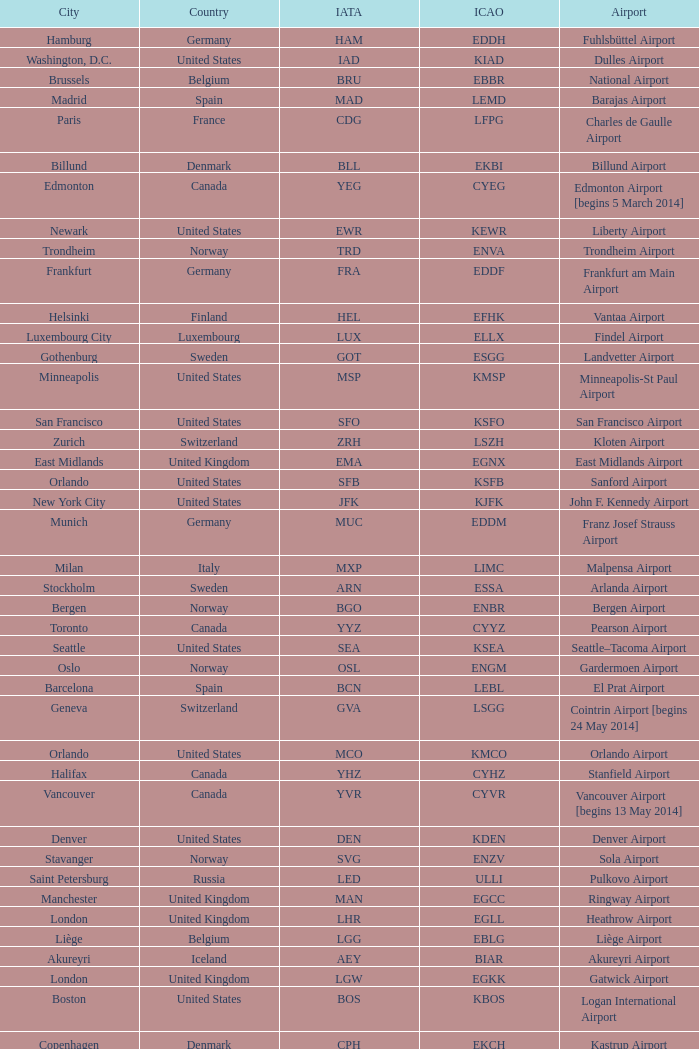What is the City with an IATA of MUC? Munich. Give me the full table as a dictionary. {'header': ['City', 'Country', 'IATA', 'ICAO', 'Airport'], 'rows': [['Hamburg', 'Germany', 'HAM', 'EDDH', 'Fuhlsbüttel Airport'], ['Washington, D.C.', 'United States', 'IAD', 'KIAD', 'Dulles Airport'], ['Brussels', 'Belgium', 'BRU', 'EBBR', 'National Airport'], ['Madrid', 'Spain', 'MAD', 'LEMD', 'Barajas Airport'], ['Paris', 'France', 'CDG', 'LFPG', 'Charles de Gaulle Airport'], ['Billund', 'Denmark', 'BLL', 'EKBI', 'Billund Airport'], ['Edmonton', 'Canada', 'YEG', 'CYEG', 'Edmonton Airport [begins 5 March 2014]'], ['Newark', 'United States', 'EWR', 'KEWR', 'Liberty Airport'], ['Trondheim', 'Norway', 'TRD', 'ENVA', 'Trondheim Airport'], ['Frankfurt', 'Germany', 'FRA', 'EDDF', 'Frankfurt am Main Airport'], ['Helsinki', 'Finland', 'HEL', 'EFHK', 'Vantaa Airport'], ['Luxembourg City', 'Luxembourg', 'LUX', 'ELLX', 'Findel Airport'], ['Gothenburg', 'Sweden', 'GOT', 'ESGG', 'Landvetter Airport'], ['Minneapolis', 'United States', 'MSP', 'KMSP', 'Minneapolis-St Paul Airport'], ['San Francisco', 'United States', 'SFO', 'KSFO', 'San Francisco Airport'], ['Zurich', 'Switzerland', 'ZRH', 'LSZH', 'Kloten Airport'], ['East Midlands', 'United Kingdom', 'EMA', 'EGNX', 'East Midlands Airport'], ['Orlando', 'United States', 'SFB', 'KSFB', 'Sanford Airport'], ['New York City', 'United States', 'JFK', 'KJFK', 'John F. Kennedy Airport'], ['Munich', 'Germany', 'MUC', 'EDDM', 'Franz Josef Strauss Airport'], ['Milan', 'Italy', 'MXP', 'LIMC', 'Malpensa Airport'], ['Stockholm', 'Sweden', 'ARN', 'ESSA', 'Arlanda Airport'], ['Bergen', 'Norway', 'BGO', 'ENBR', 'Bergen Airport'], ['Toronto', 'Canada', 'YYZ', 'CYYZ', 'Pearson Airport'], ['Seattle', 'United States', 'SEA', 'KSEA', 'Seattle–Tacoma Airport'], ['Oslo', 'Norway', 'OSL', 'ENGM', 'Gardermoen Airport'], ['Barcelona', 'Spain', 'BCN', 'LEBL', 'El Prat Airport'], ['Geneva', 'Switzerland', 'GVA', 'LSGG', 'Cointrin Airport [begins 24 May 2014]'], ['Orlando', 'United States', 'MCO', 'KMCO', 'Orlando Airport'], ['Halifax', 'Canada', 'YHZ', 'CYHZ', 'Stanfield Airport'], ['Vancouver', 'Canada', 'YVR', 'CYVR', 'Vancouver Airport [begins 13 May 2014]'], ['Denver', 'United States', 'DEN', 'KDEN', 'Denver Airport'], ['Stavanger', 'Norway', 'SVG', 'ENZV', 'Sola Airport'], ['Saint Petersburg', 'Russia', 'LED', 'ULLI', 'Pulkovo Airport'], ['Manchester', 'United Kingdom', 'MAN', 'EGCC', 'Ringway Airport'], ['London', 'United Kingdom', 'LHR', 'EGLL', 'Heathrow Airport'], ['Liège', 'Belgium', 'LGG', 'EBLG', 'Liège Airport'], ['Akureyri', 'Iceland', 'AEY', 'BIAR', 'Akureyri Airport'], ['London', 'United Kingdom', 'LGW', 'EGKK', 'Gatwick Airport'], ['Boston', 'United States', 'BOS', 'KBOS', 'Logan International Airport'], ['Copenhagen', 'Denmark', 'CPH', 'EKCH', 'Kastrup Airport'], ['Anchorage', 'United States', 'ANC', 'PANC', 'Ted Stevens Airport'], ['Reykjavík', 'Iceland', 'KEF', 'BIKF', 'Keflavik Airport'], ['Baltimore', 'United States', 'BWI', 'KBWI', 'Baltimore-Washington Airport'], ['Amsterdam', 'Netherlands', 'AMS', 'EHAM', 'Schiphol Airport'], ['Glasgow', 'United Kingdom', 'GLA', 'EGPF', 'International Airport']]} 